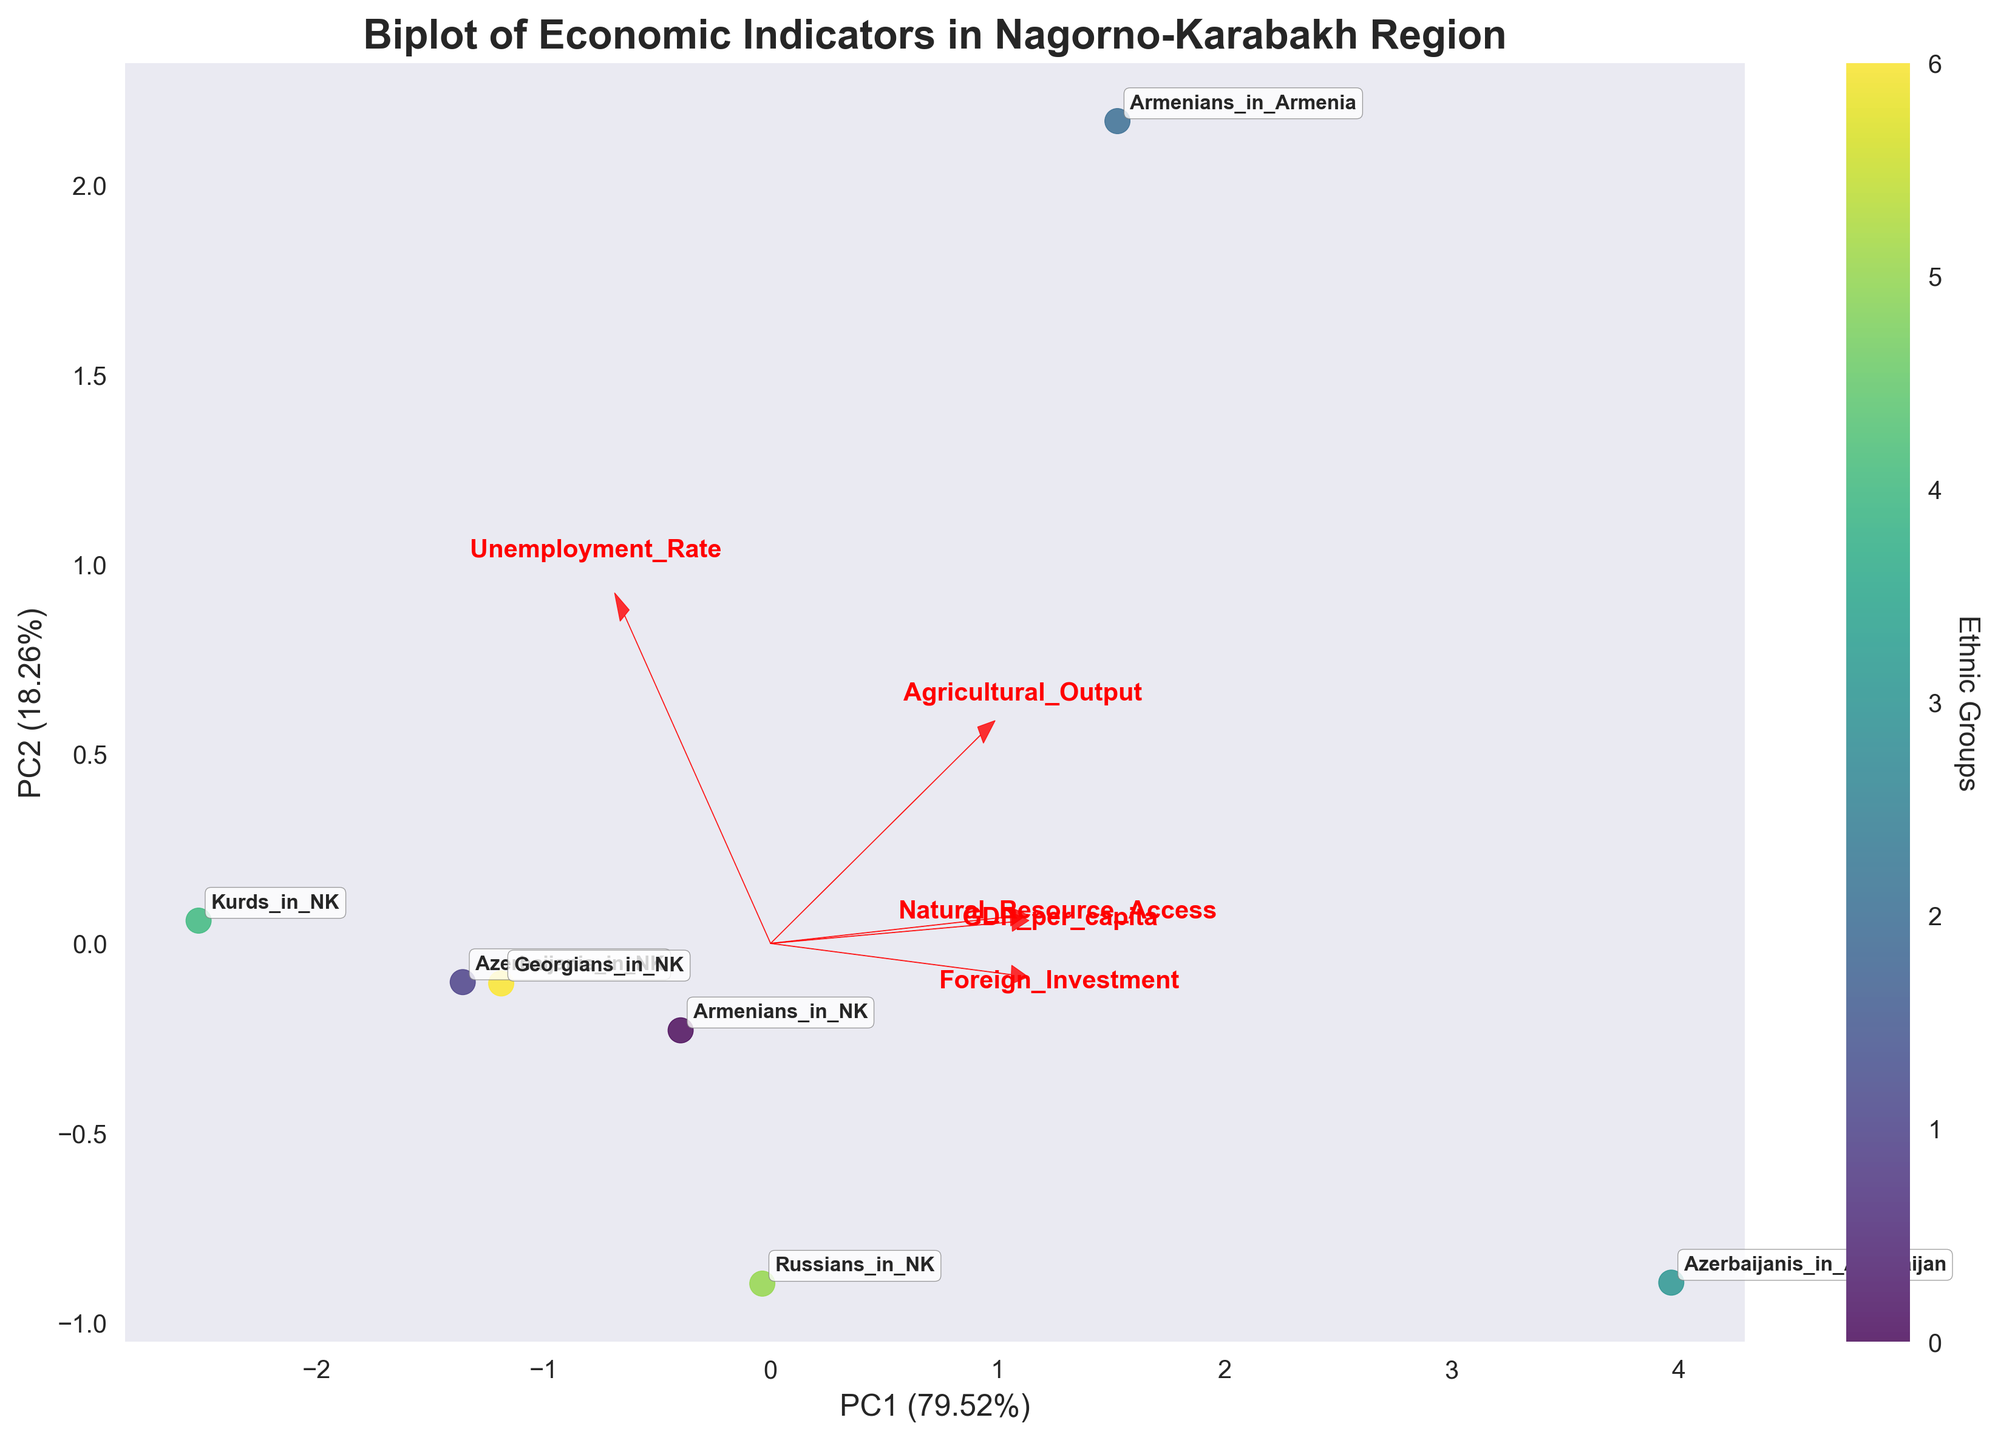What is the title of the biplot? The title of the biplot is mentioned explicitly at the top of the plot. It reads "Biplot of Economic Indicators in Nagorno-Karabakh Region".
Answer: Biplot of Economic Indicators in Nagorno-Karabakh Region Which ethnic group has the lowest GDP per capita according to the biplot? To determine the lowest GDP per capita, locate the position of the ethnic groups along the direction associated with the GDP per capita loading arrow. The Kurds in NK have the smallest projection in this direction.
Answer: Kurds in NK Which economic indicator is most strongly correlated with PC1? The direction and length of the loading arrows indicate the correlation of each economic indicator with the principal components. The Foreign Investment arrow is most aligned with the PC1 axis, suggesting it is most strongly correlated with PC1.
Answer: Foreign Investment What is the approximate PC1 value for the Armenians in Armenia? Locate the Armenians in Armenia label on the plot and find its projection on the PC1 axis. Despite exact numbers not provided, we can visually approximate this value, which is around the highest part along PC1.
Answer: Approximately 2.5 Which ethnic group has the highest unemployment rate? Refer to the arrow associated with the Unemployment Rate. The group that has the highest projection in the direction of this arrow is Armenians in Armenia.
Answer: Armenians in Armenia How does the access to natural resources for Azerbaijanis in NK compare to that of Russians in NK? Identify the positions of Azerbaijanis in NK and Russians in NK. Compare their projections along the Natural Resource Access loading arrow. Azerbaijanis in NK have a lower projection, indicating less access.
Answer: Less What general trend can be inferred about the relationship between Foreign Investment and GDP per capita? Examine the angles between the loading arrows for Foreign Investment and GDP per capita. They are fairly close, indicating a positive correlation; higher Foreign Investment tends to be associated with higher GDP per capita.
Answer: Positive correlation How are the Agricultural Output and Unemployment Rate related according to the biplot? Look at the angle between the Agricultural Output and Unemployment Rate loading vectors. These arrows point in roughly opposite directions, suggesting a negative correlation.
Answer: Negative correlation Name the ethnic group with the highest Agricultural Output. Locate the Agricultural Output arrow and determine which ethnic group's projection is furthest in that direction. Armenians in Armenia have the highest projection along this axis.
Answer: Armenians in Armenia Which two ethnic groups are closest to each other on the biplot based on the PC1 and PC2 values? Identify the two ethnic groups that are spatially closest on the biplot when considering both PC1 and PC2 axes. Armenians in NK and Russians in NK are closest to each other.
Answer: Armenians in NK and Russians in NK 